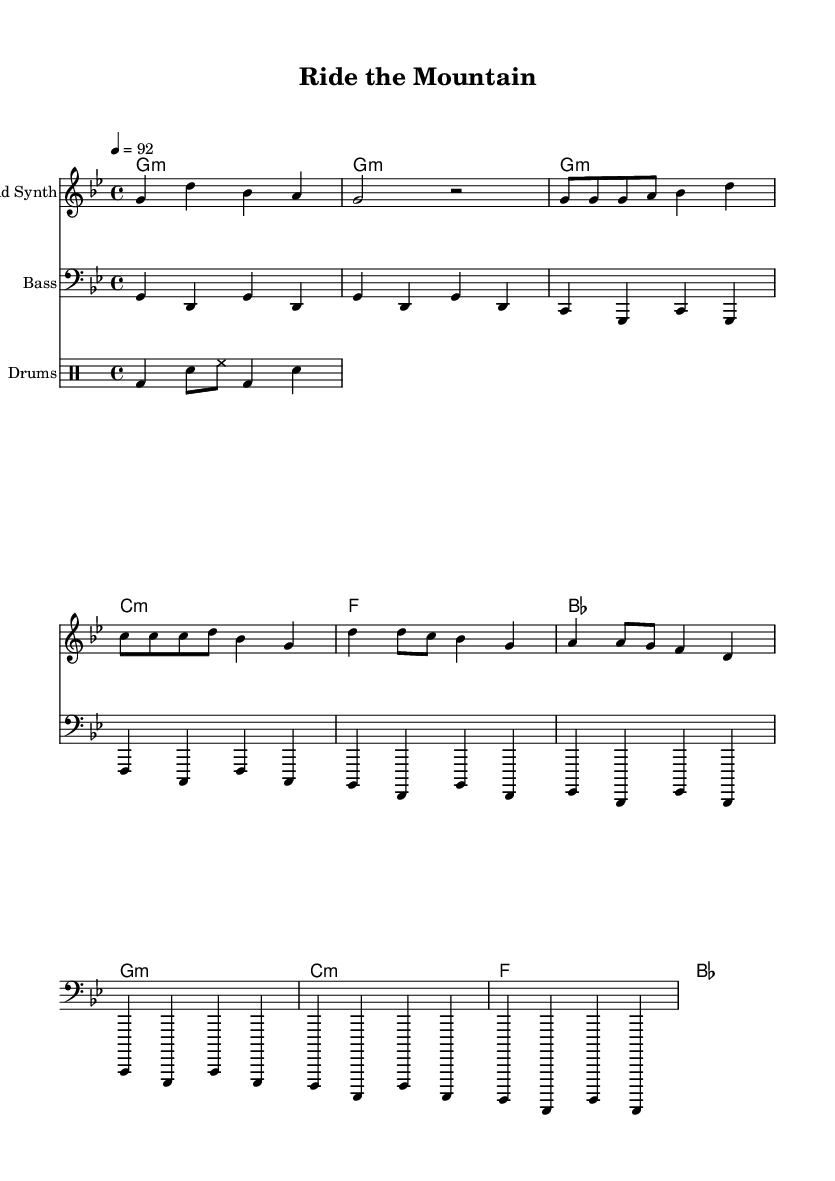What is the time signature of this music? The time signature is indicated at the beginning of the sheet music, where it shows 4/4. This means there are four beats in each measure and the quarter note gets one beat.
Answer: 4/4 What is the tempo marking for this piece? The tempo marking is specified as 4 = 92, which indicates that there should be 92 beats per minute. This marking helps musicians understand the speed at which to play the piece.
Answer: 92 What is the key signature of this piece? The key signature is indicated at the beginning of the music. The presence of 5 flats indicates the key is G minor. This affects the notes played throughout the piece.
Answer: G minor How many measures are in the chorus section? To determine this, count the measures indicated in the chorus, which includes 4 distinct measures as shown in the sheet music before moving onto another section or ending.
Answer: 4 What instrument is labeled as "Lead Synth" in the sheet music? The staff labeled "Lead Synth" indicates that this is the instrument that plays the melodies, which is typically a synthesizer sound in a hip-hop context and is visually differentiated in the score.
Answer: Lead Synth What is the chord progression used in the verse section? By analyzing the chord mode notations associated with the verse, we find it follows the progression: G minor, C minor, F, B flat. This outlines how the harmony moves throughout the verse.
Answer: G minor, C minor, F, B flat What type of rhythm is indicated by the drum pattern? In the drum pattern, we can observe it includes a bass drum, snare, and hi-hat. The rhythmic arrangement corresponds to a common hip-hop style, providing a foundational beat throughout the piece.
Answer: Hip-hop 